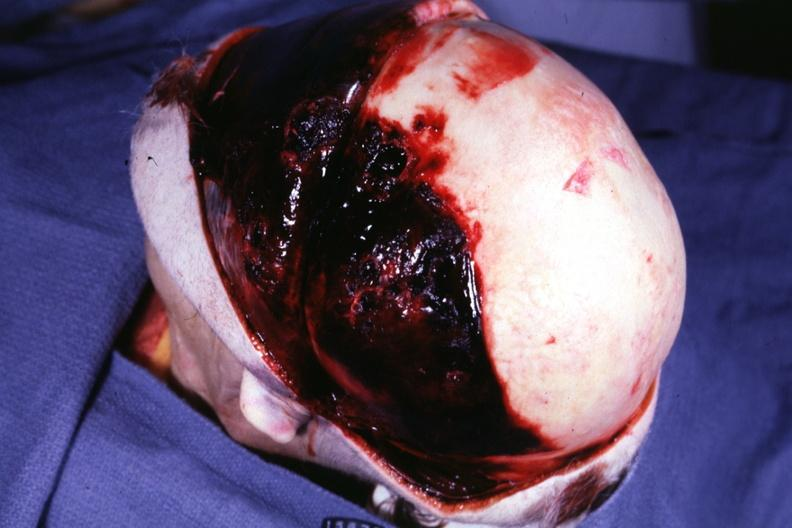what is present?
Answer the question using a single word or phrase. Temporal muscle hemorrhage 